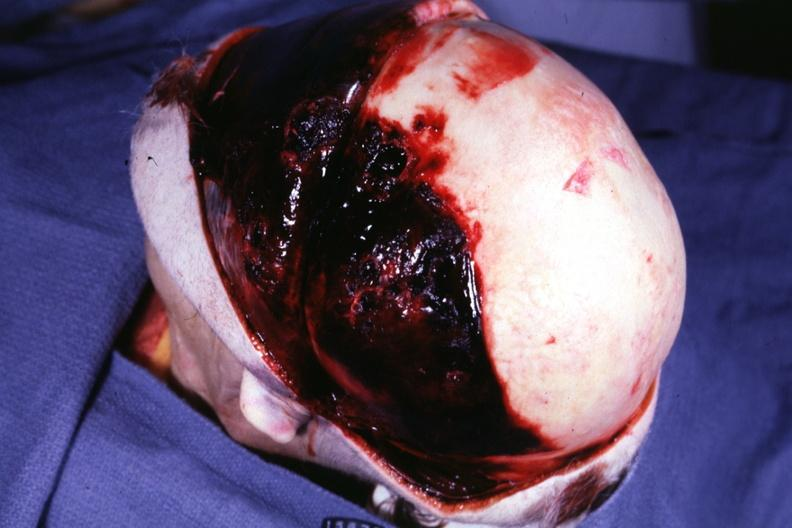what is present?
Answer the question using a single word or phrase. Temporal muscle hemorrhage 